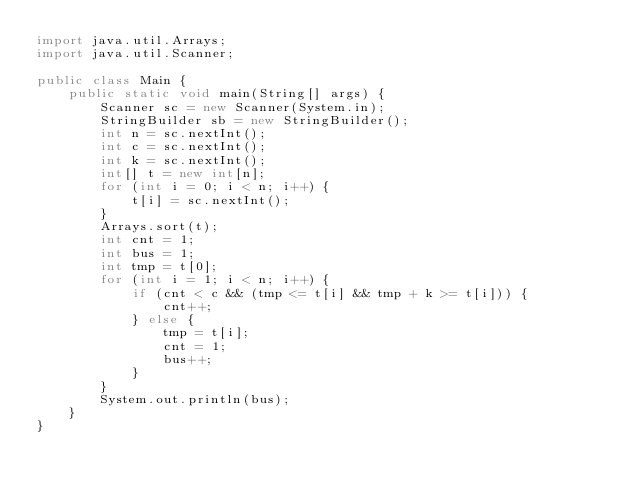<code> <loc_0><loc_0><loc_500><loc_500><_Java_>import java.util.Arrays;
import java.util.Scanner;

public class Main {
	public static void main(String[] args) {
		Scanner sc = new Scanner(System.in);
		StringBuilder sb = new StringBuilder();
		int n = sc.nextInt();
		int c = sc.nextInt();
		int k = sc.nextInt();
		int[] t = new int[n];
		for (int i = 0; i < n; i++) {
			t[i] = sc.nextInt();
		}
		Arrays.sort(t);
		int cnt = 1;
		int bus = 1;
		int tmp = t[0];
		for (int i = 1; i < n; i++) {
			if (cnt < c && (tmp <= t[i] && tmp + k >= t[i])) {
				cnt++;
			} else {
				tmp = t[i];
				cnt = 1;
				bus++;
			}
		}
		System.out.println(bus);
	}
}
</code> 